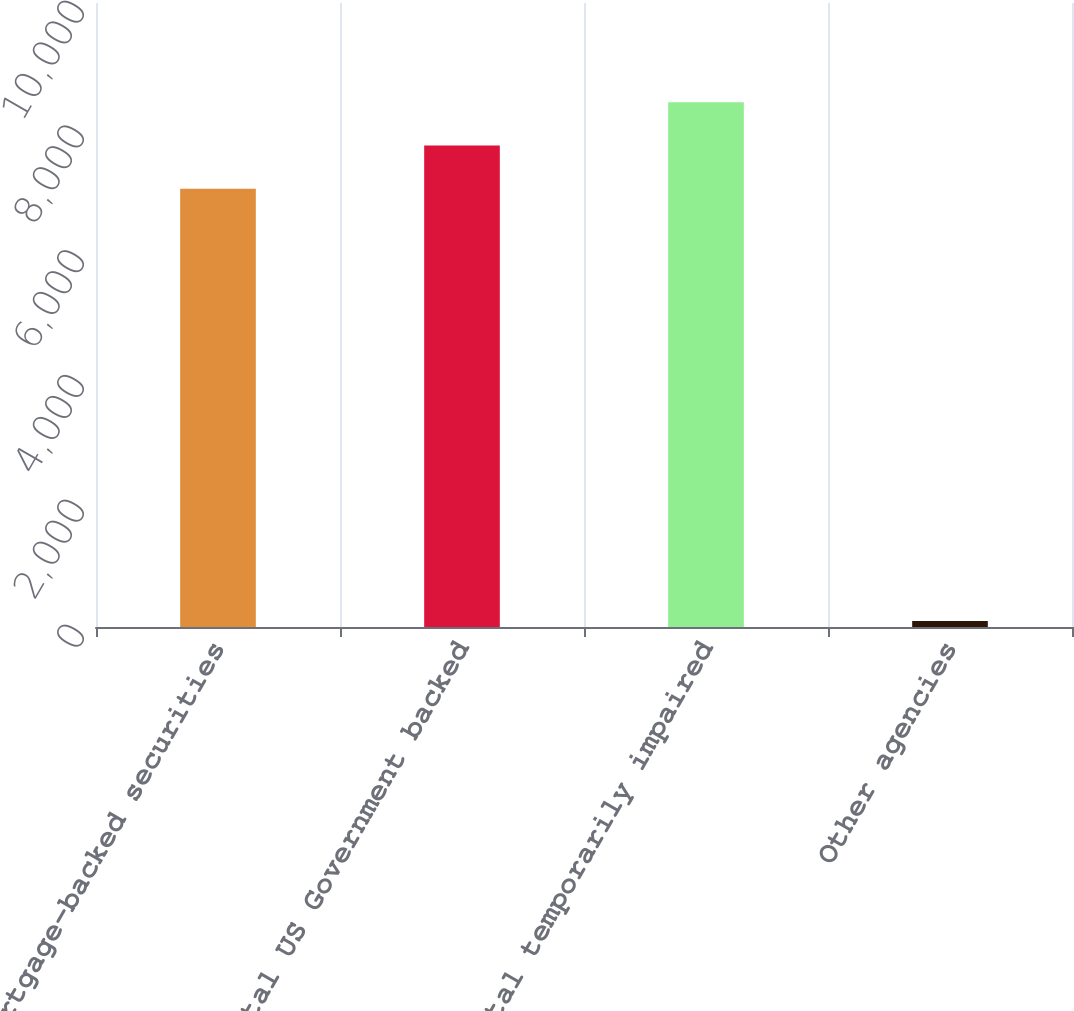Convert chart to OTSL. <chart><loc_0><loc_0><loc_500><loc_500><bar_chart><fcel>Mortgage-backed securities<fcel>Total US Government backed<fcel>Total temporarily impaired<fcel>Other agencies<nl><fcel>7023<fcel>7715.6<fcel>8408.2<fcel>97<nl></chart> 